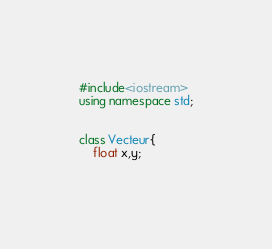<code> <loc_0><loc_0><loc_500><loc_500><_C++_>#include<iostream>
using namespace std;


class Vecteur{
	float x,y;
	</code> 